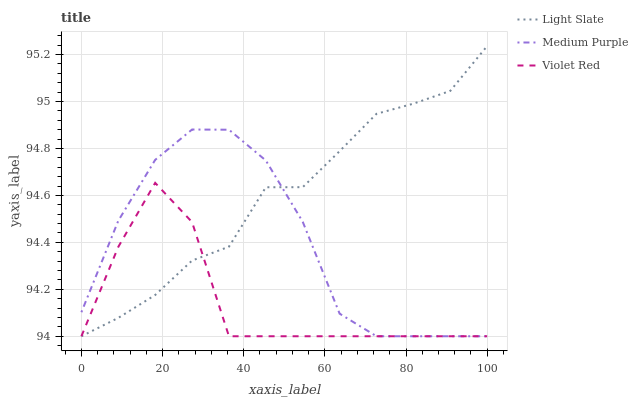Does Violet Red have the minimum area under the curve?
Answer yes or no. Yes. Does Light Slate have the maximum area under the curve?
Answer yes or no. Yes. Does Medium Purple have the minimum area under the curve?
Answer yes or no. No. Does Medium Purple have the maximum area under the curve?
Answer yes or no. No. Is Light Slate the smoothest?
Answer yes or no. Yes. Is Violet Red the roughest?
Answer yes or no. Yes. Is Medium Purple the smoothest?
Answer yes or no. No. Is Medium Purple the roughest?
Answer yes or no. No. Does Light Slate have the lowest value?
Answer yes or no. Yes. Does Light Slate have the highest value?
Answer yes or no. Yes. Does Medium Purple have the highest value?
Answer yes or no. No. Does Violet Red intersect Light Slate?
Answer yes or no. Yes. Is Violet Red less than Light Slate?
Answer yes or no. No. Is Violet Red greater than Light Slate?
Answer yes or no. No. 